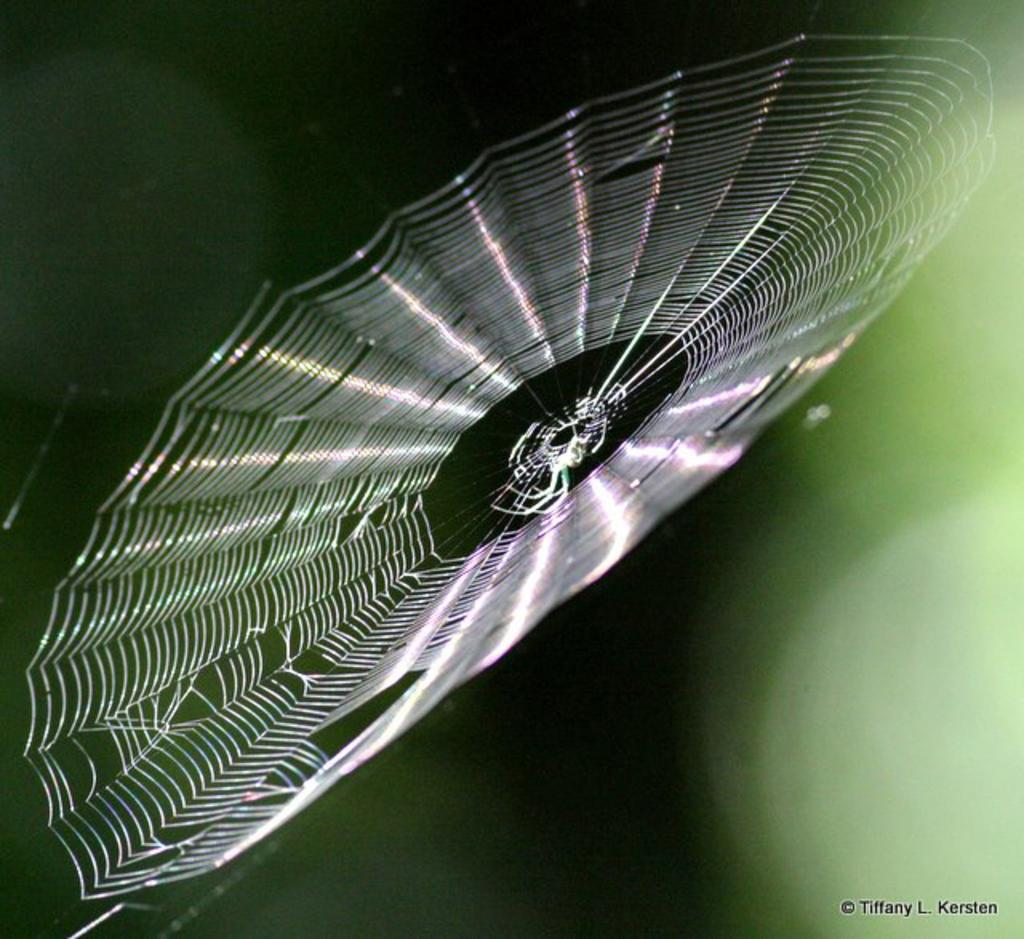What is the main subject of the image? The main subject of the image is a spider net. Is there anything else present in the spider net? Yes, there is a spider in the image. What else can be seen in the image besides the spider net and spider? There is text in the image. What color is the background of the image? The background of the image is green. What time of day is it in the image, and is there a stranger present? The time of day is not mentioned in the image, and there is no stranger present. Can you see a wren in the image? There is no wren present in the image. 